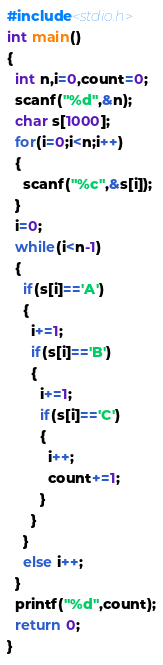<code> <loc_0><loc_0><loc_500><loc_500><_C_>#include<stdio.h>
int main()
{
  int n,i=0,count=0;
  scanf("%d",&n);
  char s[1000];
  for(i=0;i<n;i++)
  {
    scanf("%c",&s[i]);
  }
  i=0;
  while(i<n-1)
  {
    if(s[i]=='A')
    {
      i+=1;
      if(s[i]=='B')
      {
        i+=1;
        if(s[i]=='C')
        {
          i++;
          count+=1;
        }
      }
    }
    else i++;
  }
  printf("%d",count);
  return 0;
}</code> 